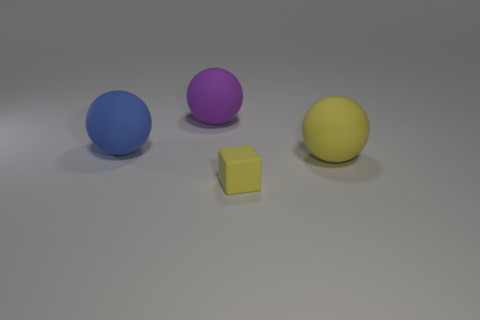Is the large object that is in front of the blue object made of the same material as the blue object?
Ensure brevity in your answer.  Yes. Is there anything else that is the same size as the yellow matte cube?
Provide a short and direct response. No. Is the number of big matte balls in front of the large yellow thing less than the number of large rubber objects that are to the left of the tiny object?
Keep it short and to the point. Yes. Is there anything else that has the same shape as the tiny matte thing?
Give a very brief answer. No. What is the material of the large object that is the same color as the tiny thing?
Offer a very short reply. Rubber. There is a object on the right side of the yellow thing in front of the big yellow matte thing; what number of large blue matte spheres are to the right of it?
Provide a short and direct response. 0. There is a tiny yellow matte thing; how many large blue rubber balls are on the left side of it?
Your answer should be very brief. 1. How many other large blue objects are the same material as the blue object?
Provide a succinct answer. 0. There is a small object that is the same material as the big purple thing; what is its color?
Give a very brief answer. Yellow. There is a ball in front of the blue object; is it the same size as the matte cube?
Offer a very short reply. No. 